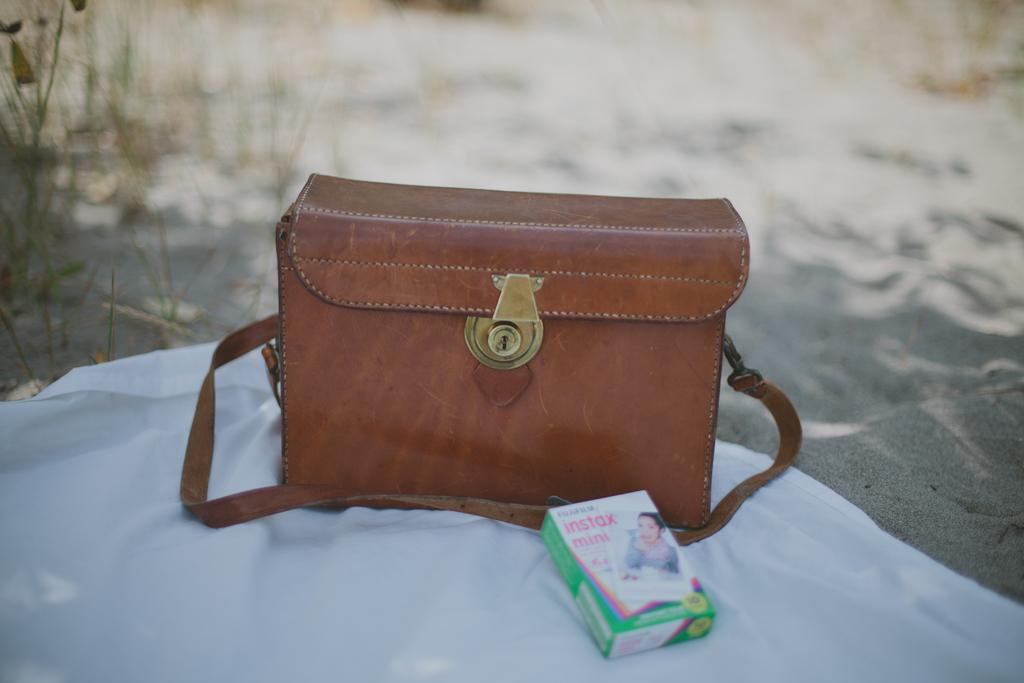What is the locked item in the image? There is a bag with a lock in the image. What other item can be seen in the image? There is a mint box in the image. On what surface are the bag and mint box placed? The bag and mint box are placed on a white cloth. Where are the bag and mint box located? The items are on the floor. What can be seen in the background of the image? Trees are visible in the background of the image. What type of fear can be seen on the faces of the trees in the image? There are no faces or expressions of fear on the trees in the image, as trees do not have faces or emotions. 